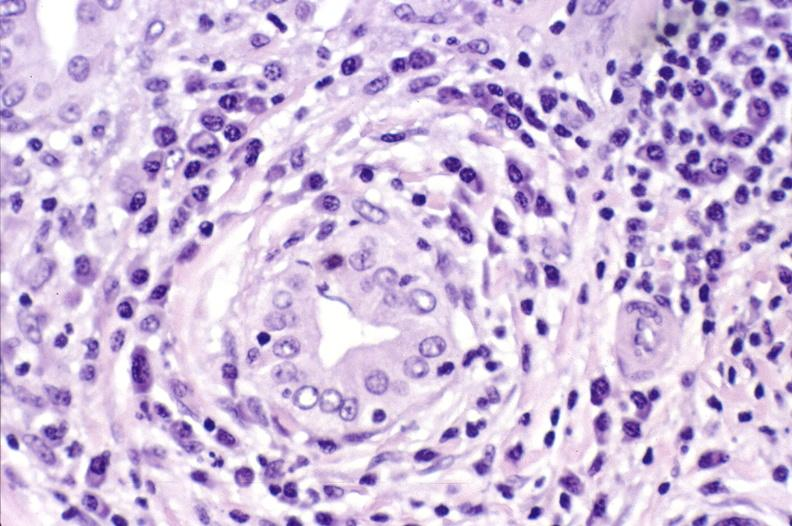does granuloma show primary biliary cirrhosis?
Answer the question using a single word or phrase. No 